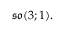Convert formula to latex. <formula><loc_0><loc_0><loc_500><loc_500>{ \mathfrak { s o } } ( 3 ; 1 ) .</formula> 